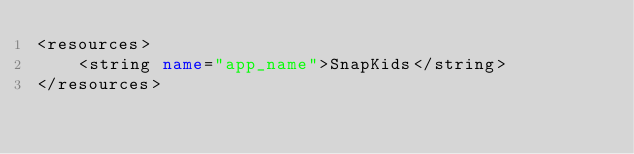<code> <loc_0><loc_0><loc_500><loc_500><_XML_><resources>
    <string name="app_name">SnapKids</string>
</resources>
</code> 